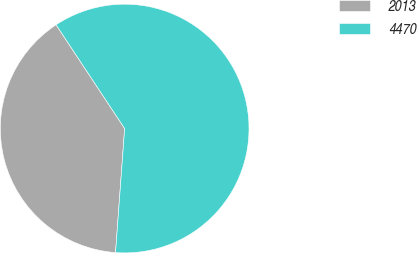Convert chart. <chart><loc_0><loc_0><loc_500><loc_500><pie_chart><fcel>2013<fcel>4470<nl><fcel>39.54%<fcel>60.46%<nl></chart> 